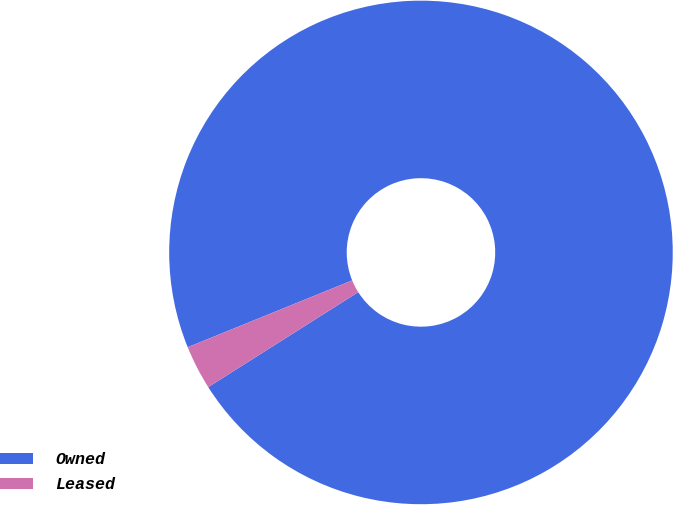Convert chart to OTSL. <chart><loc_0><loc_0><loc_500><loc_500><pie_chart><fcel>Owned<fcel>Leased<nl><fcel>97.16%<fcel>2.84%<nl></chart> 